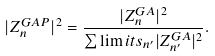Convert formula to latex. <formula><loc_0><loc_0><loc_500><loc_500>| Z _ { n } ^ { G A P } | ^ { 2 } = \frac { | Z _ { n } ^ { G A } | ^ { 2 } } { \sum \lim i t s _ { n ^ { \prime } } | Z _ { n ^ { \prime } } ^ { G A } | ^ { 2 } } .</formula> 